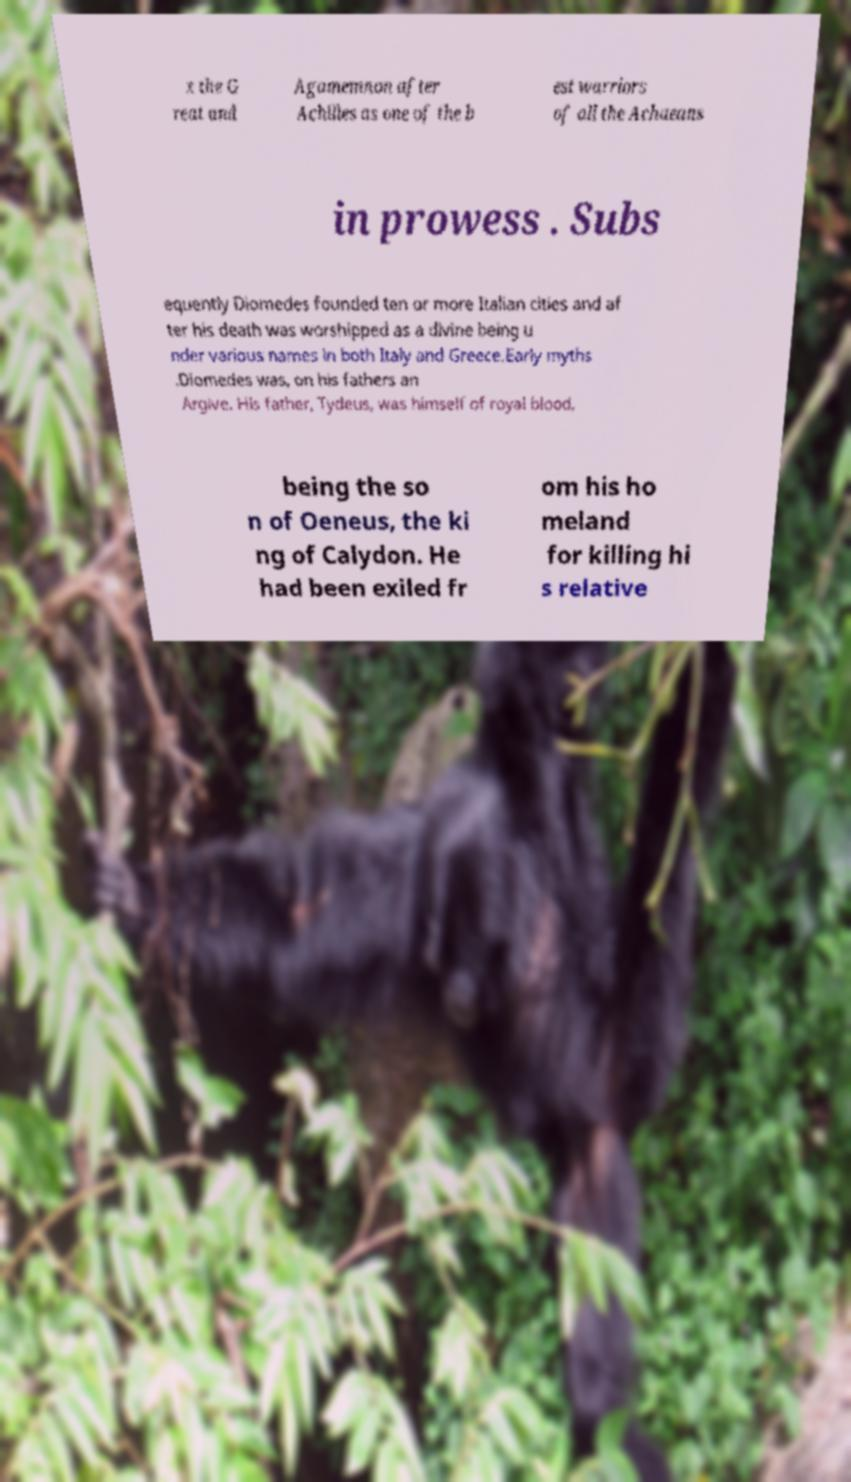Please read and relay the text visible in this image. What does it say? x the G reat and Agamemnon after Achilles as one of the b est warriors of all the Achaeans in prowess . Subs equently Diomedes founded ten or more Italian cities and af ter his death was worshipped as a divine being u nder various names in both Italy and Greece.Early myths .Diomedes was, on his fathers an Argive. His father, Tydeus, was himself of royal blood, being the so n of Oeneus, the ki ng of Calydon. He had been exiled fr om his ho meland for killing hi s relative 